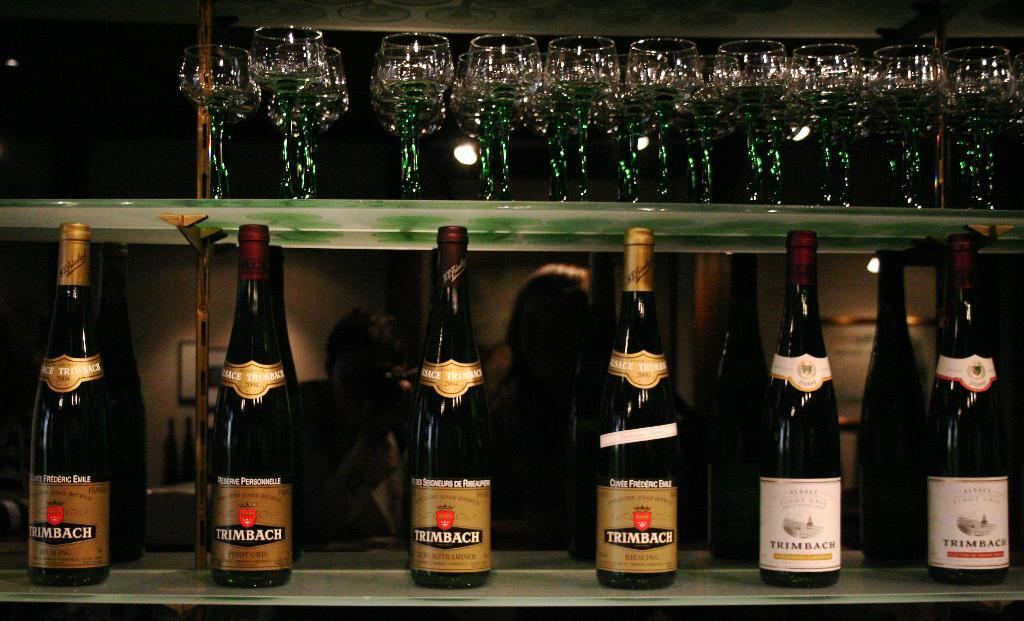<image>
Summarize the visual content of the image. Bottles on a counter with labels that says "TRIMBACH" on it. 